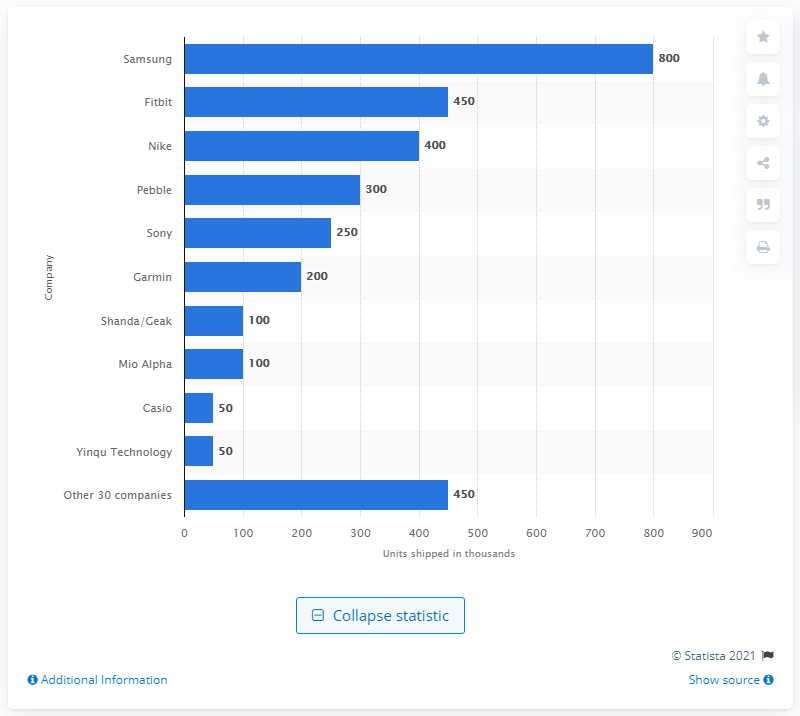Point out several critical features in this image. In 2013, Samsung sold 800 smartwatches. 